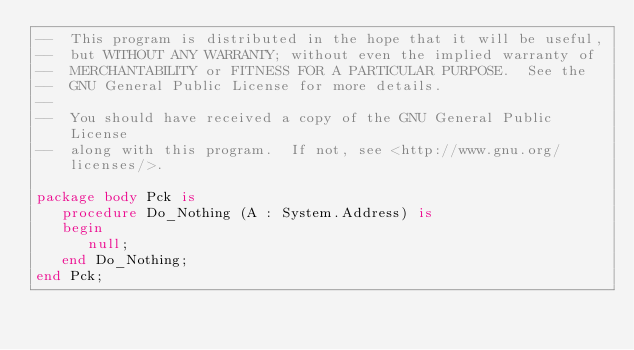Convert code to text. <code><loc_0><loc_0><loc_500><loc_500><_Ada_>--  This program is distributed in the hope that it will be useful,
--  but WITHOUT ANY WARRANTY; without even the implied warranty of
--  MERCHANTABILITY or FITNESS FOR A PARTICULAR PURPOSE.  See the
--  GNU General Public License for more details.
--
--  You should have received a copy of the GNU General Public License
--  along with this program.  If not, see <http://www.gnu.org/licenses/>.

package body Pck is
   procedure Do_Nothing (A : System.Address) is
   begin
      null;
   end Do_Nothing;
end Pck;
</code> 